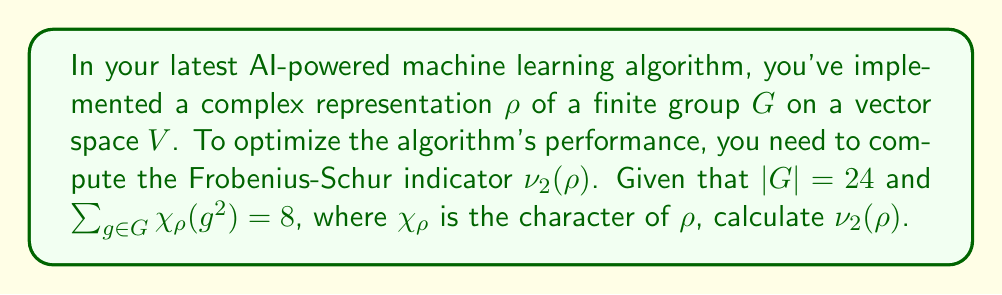Can you solve this math problem? Let's approach this step-by-step:

1) The Frobenius-Schur indicator $\nu_2(\rho)$ for a complex representation $\rho$ of a finite group $G$ is given by the formula:

   $$\nu_2(\rho) = \frac{1}{|G|} \sum_{g \in G} \chi_\rho(g^2)$$

2) We are given that $|G| = 24$ and $\sum_{g \in G} \chi_\rho(g^2) = 8$.

3) Substituting these values into the formula:

   $$\nu_2(\rho) = \frac{1}{24} \cdot 8$$

4) Simplifying:

   $$\nu_2(\rho) = \frac{1}{3}$$

5) The Frobenius-Schur indicator can only take values in $\{-1, 0, 1\}$ for irreducible representations. However, for reducible representations (which is likely the case in a complex machine learning algorithm), it can take other rational values.

6) In this case, $\frac{1}{3}$ is a valid result for $\nu_2(\rho)$.
Answer: $\frac{1}{3}$ 